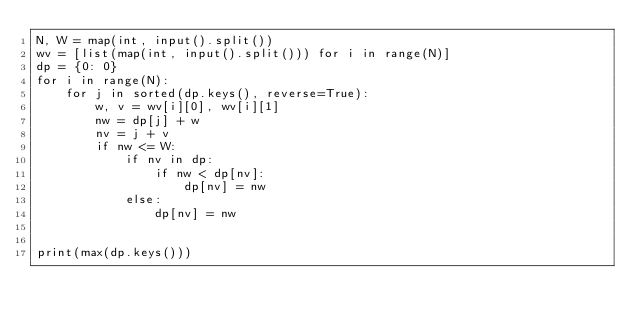Convert code to text. <code><loc_0><loc_0><loc_500><loc_500><_Python_>N, W = map(int, input().split())
wv = [list(map(int, input().split())) for i in range(N)]
dp = {0: 0}
for i in range(N):
    for j in sorted(dp.keys(), reverse=True):
        w, v = wv[i][0], wv[i][1]
        nw = dp[j] + w
        nv = j + v
        if nw <= W:
            if nv in dp:
                if nw < dp[nv]:
                    dp[nv] = nw
            else:
                dp[nv] = nw


print(max(dp.keys()))</code> 